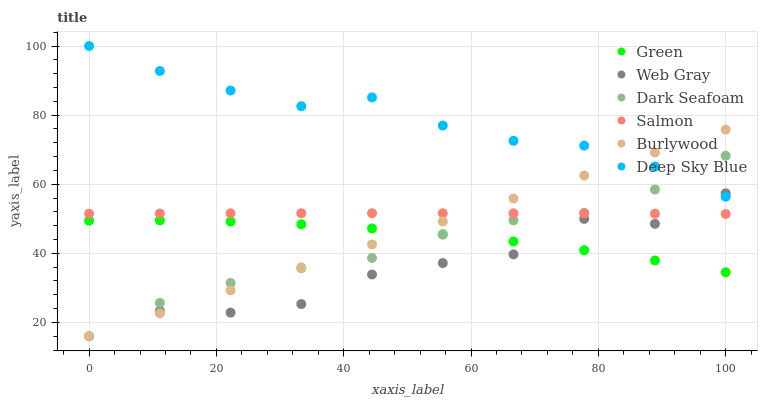Does Web Gray have the minimum area under the curve?
Answer yes or no. Yes. Does Deep Sky Blue have the maximum area under the curve?
Answer yes or no. Yes. Does Burlywood have the minimum area under the curve?
Answer yes or no. No. Does Burlywood have the maximum area under the curve?
Answer yes or no. No. Is Burlywood the smoothest?
Answer yes or no. Yes. Is Web Gray the roughest?
Answer yes or no. Yes. Is Salmon the smoothest?
Answer yes or no. No. Is Salmon the roughest?
Answer yes or no. No. Does Web Gray have the lowest value?
Answer yes or no. Yes. Does Salmon have the lowest value?
Answer yes or no. No. Does Deep Sky Blue have the highest value?
Answer yes or no. Yes. Does Burlywood have the highest value?
Answer yes or no. No. Is Green less than Salmon?
Answer yes or no. Yes. Is Deep Sky Blue greater than Green?
Answer yes or no. Yes. Does Green intersect Burlywood?
Answer yes or no. Yes. Is Green less than Burlywood?
Answer yes or no. No. Is Green greater than Burlywood?
Answer yes or no. No. Does Green intersect Salmon?
Answer yes or no. No. 